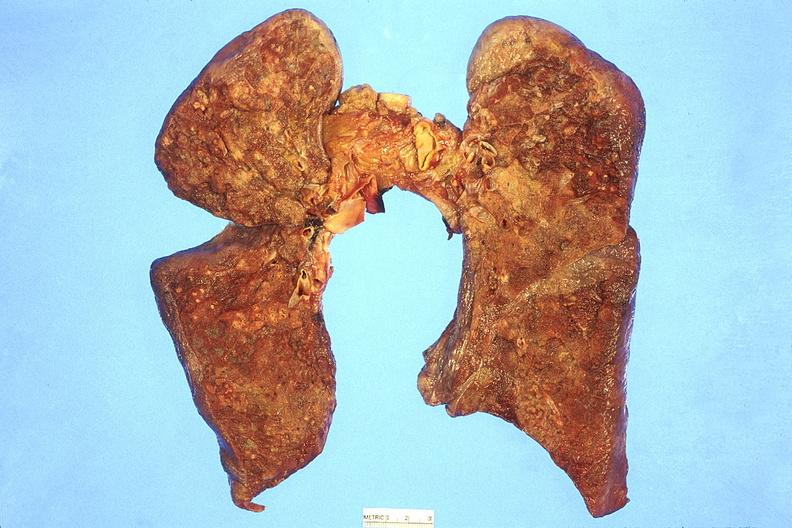what does this image show?
Answer the question using a single word or phrase. Lung 